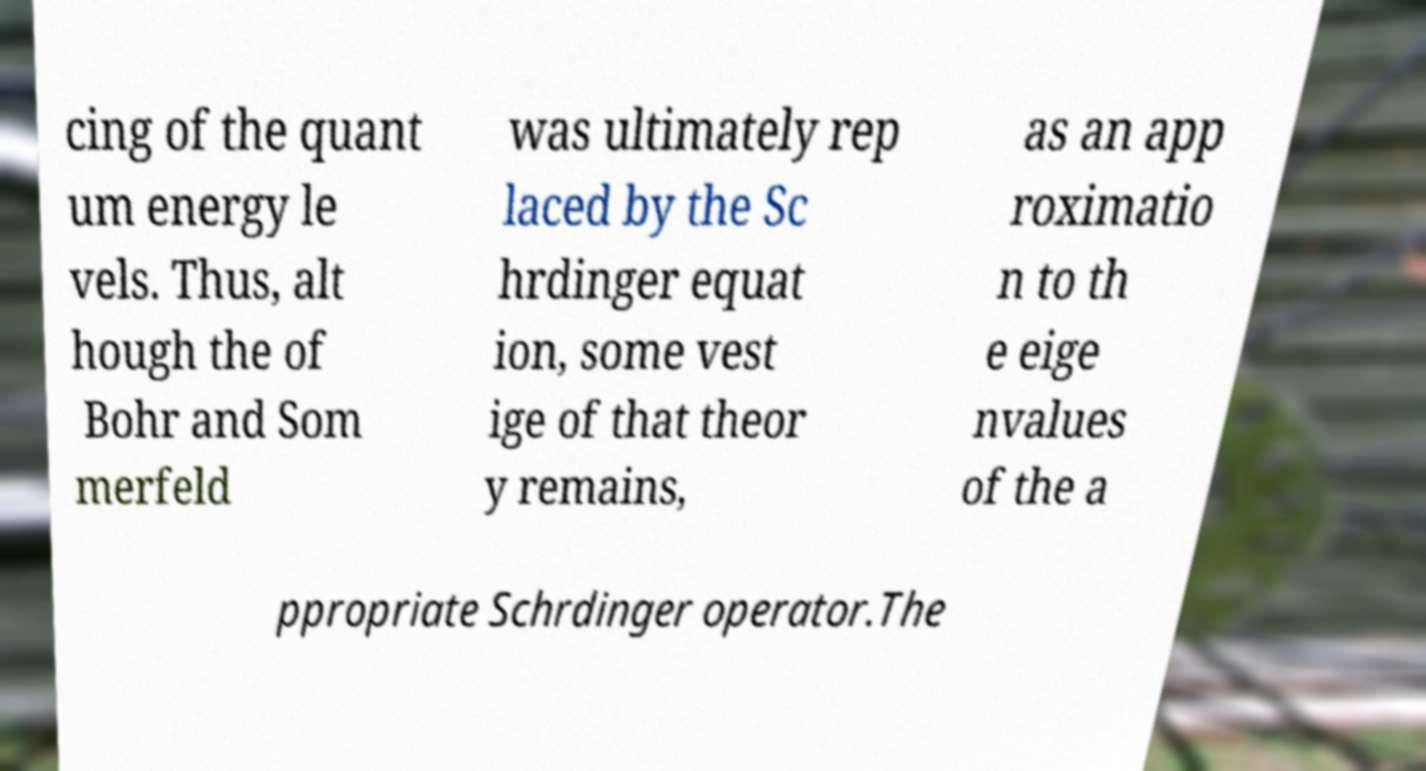What messages or text are displayed in this image? I need them in a readable, typed format. cing of the quant um energy le vels. Thus, alt hough the of Bohr and Som merfeld was ultimately rep laced by the Sc hrdinger equat ion, some vest ige of that theor y remains, as an app roximatio n to th e eige nvalues of the a ppropriate Schrdinger operator.The 